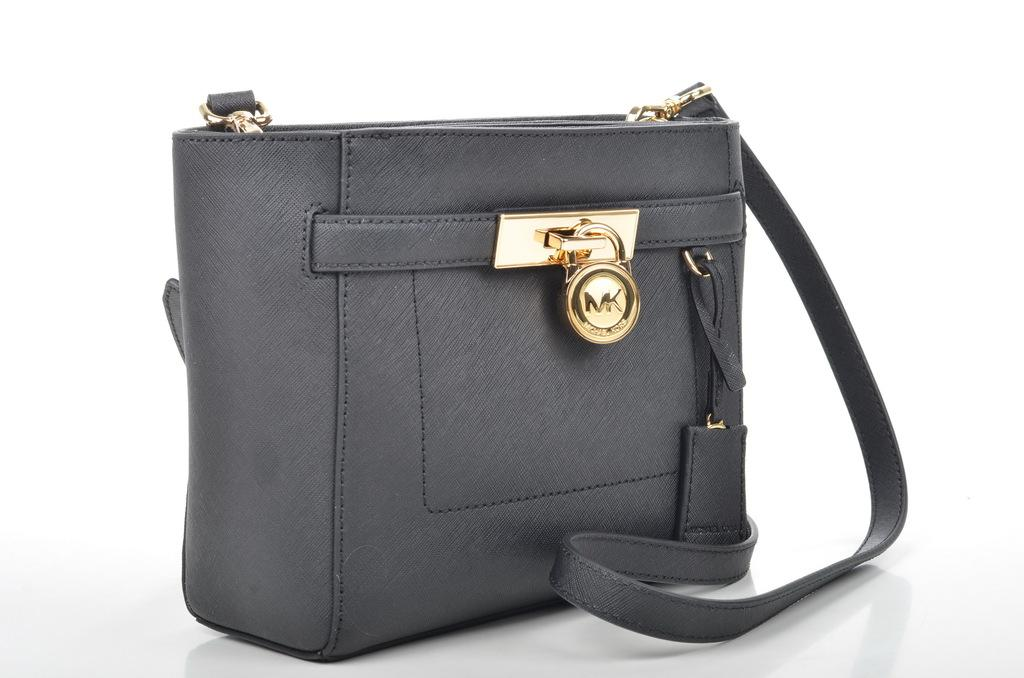What material is the handbag made of? The handbag is made of leather. Does the handbag have any security features? Yes, the handbag has a safety locking system. What type of noise does the cub make while playing with the handbag in the image? There is no cub present in the image, and therefore no such activity can be observed. 